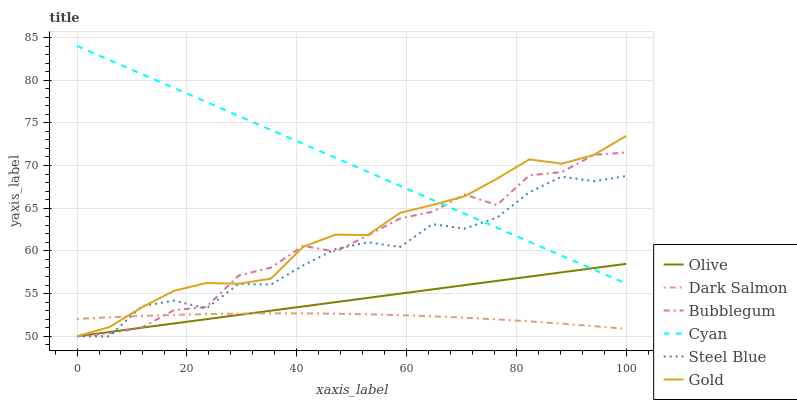Does Dark Salmon have the minimum area under the curve?
Answer yes or no. Yes. Does Cyan have the maximum area under the curve?
Answer yes or no. Yes. Does Bubblegum have the minimum area under the curve?
Answer yes or no. No. Does Bubblegum have the maximum area under the curve?
Answer yes or no. No. Is Olive the smoothest?
Answer yes or no. Yes. Is Steel Blue the roughest?
Answer yes or no. Yes. Is Dark Salmon the smoothest?
Answer yes or no. No. Is Dark Salmon the roughest?
Answer yes or no. No. Does Gold have the lowest value?
Answer yes or no. Yes. Does Dark Salmon have the lowest value?
Answer yes or no. No. Does Cyan have the highest value?
Answer yes or no. Yes. Does Bubblegum have the highest value?
Answer yes or no. No. Is Dark Salmon less than Cyan?
Answer yes or no. Yes. Is Cyan greater than Dark Salmon?
Answer yes or no. Yes. Does Gold intersect Bubblegum?
Answer yes or no. Yes. Is Gold less than Bubblegum?
Answer yes or no. No. Is Gold greater than Bubblegum?
Answer yes or no. No. Does Dark Salmon intersect Cyan?
Answer yes or no. No. 